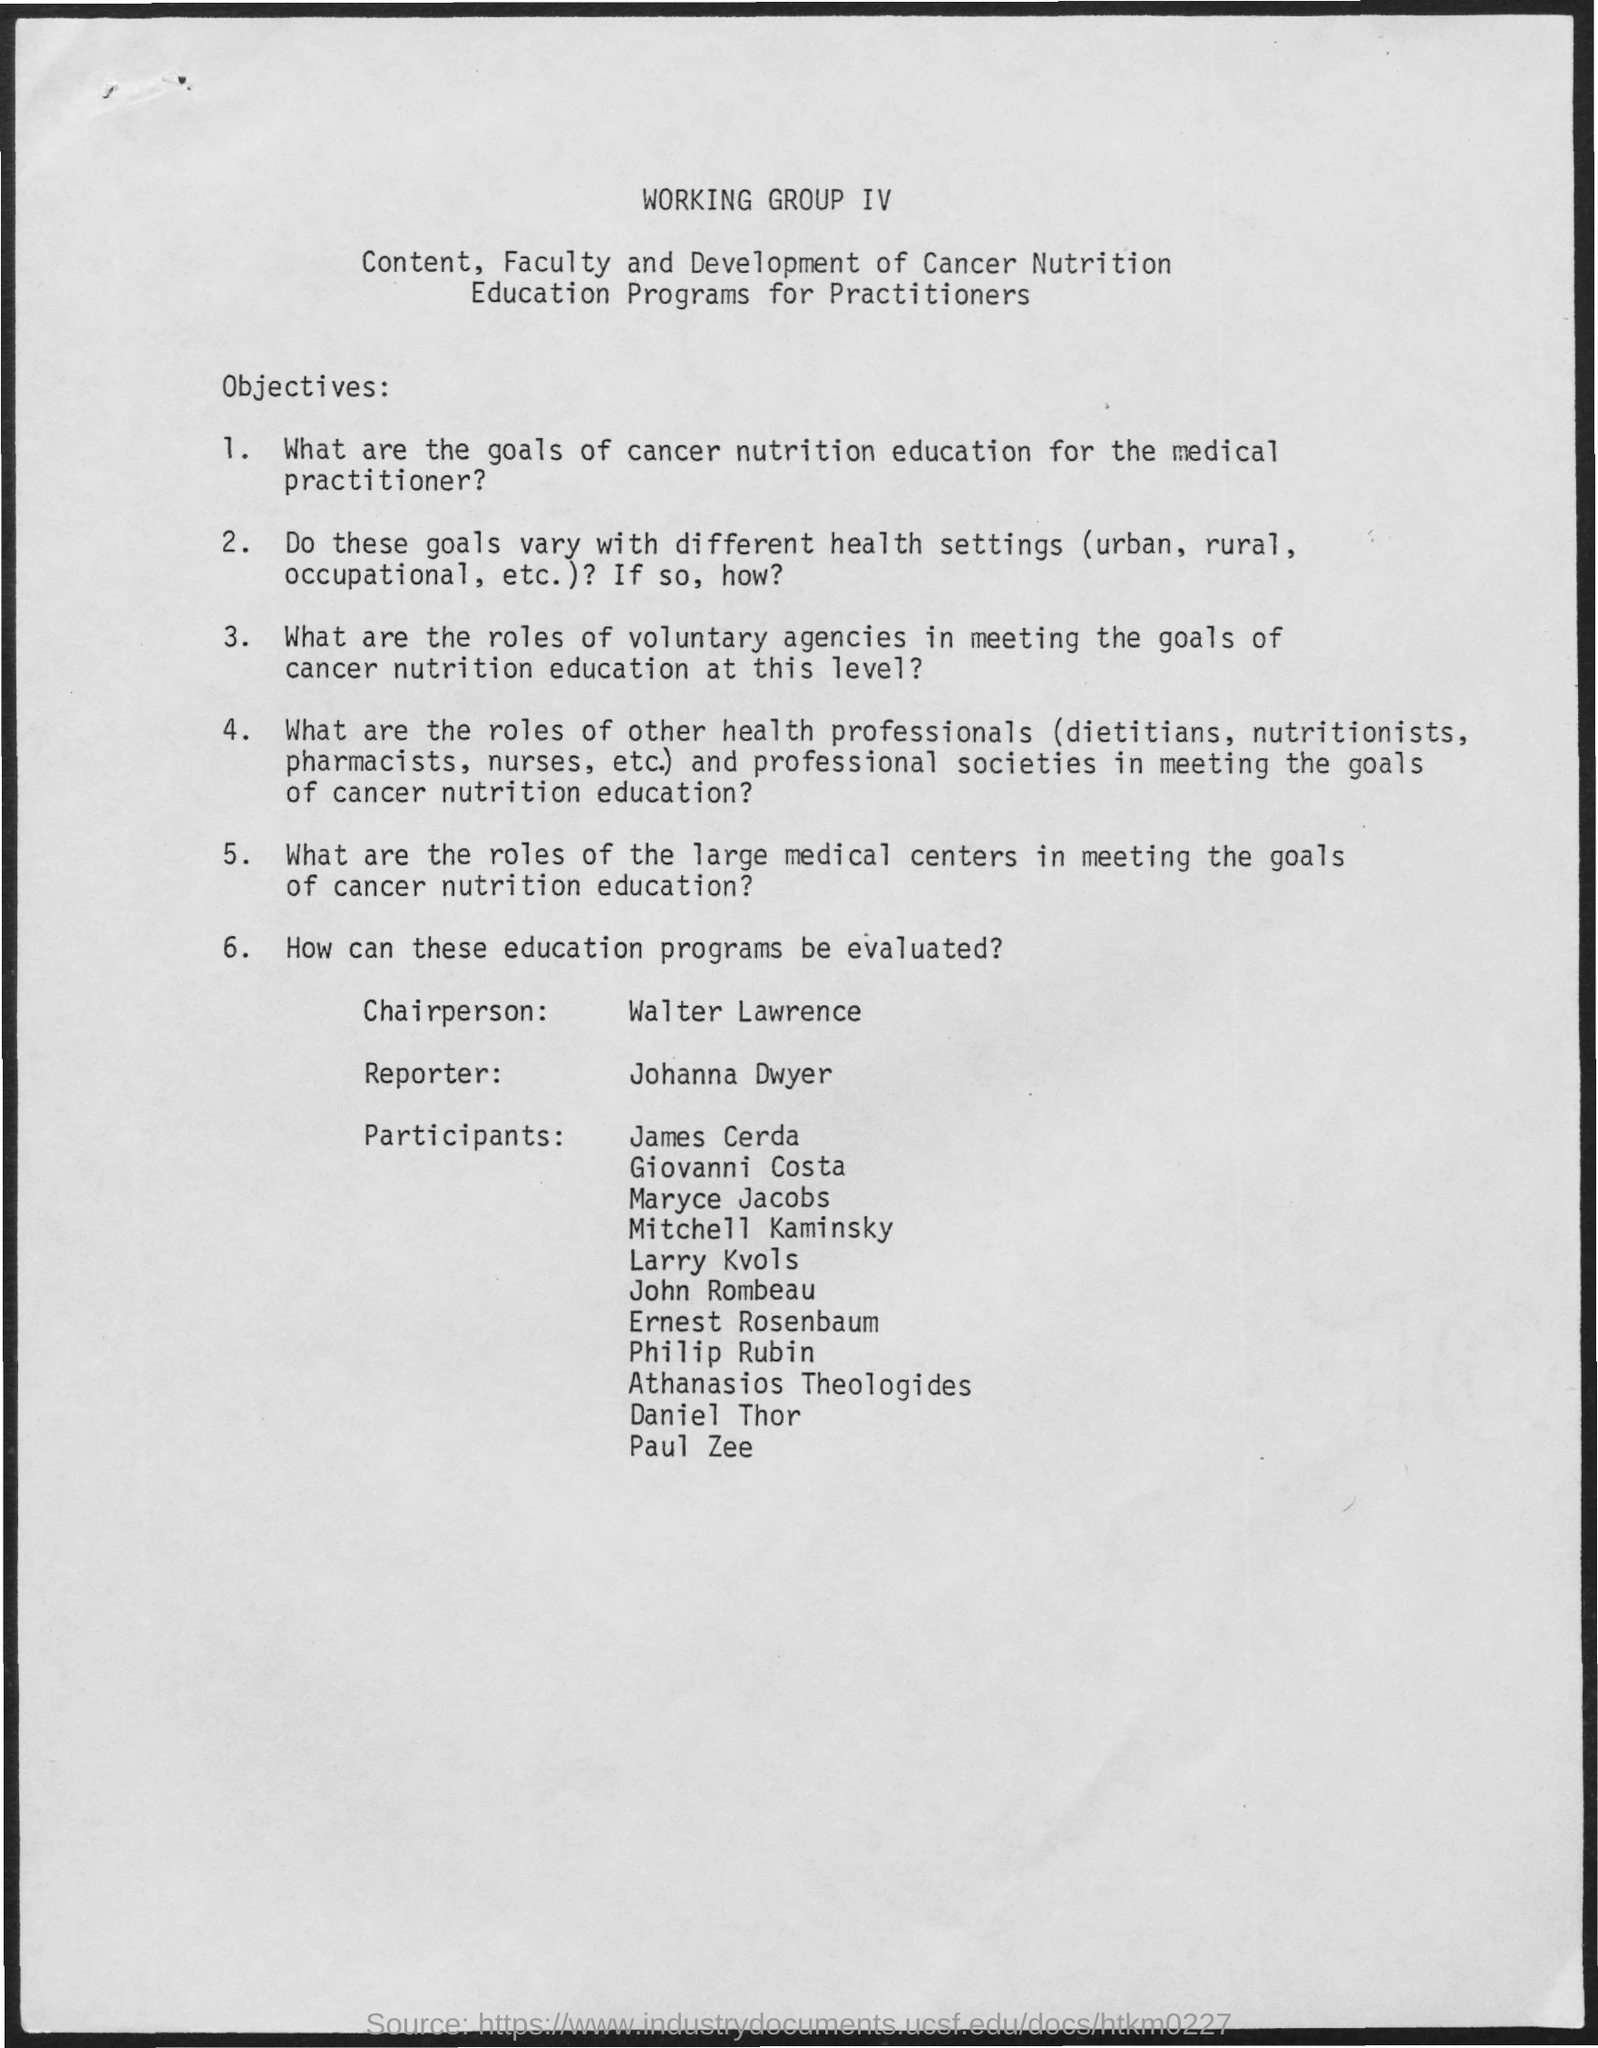Draw attention to some important aspects in this diagram. The reporter's name mentioned in the given page is Johanna Dwyer. The chairperson's name mentioned in the given page is Walter Lawrence. 